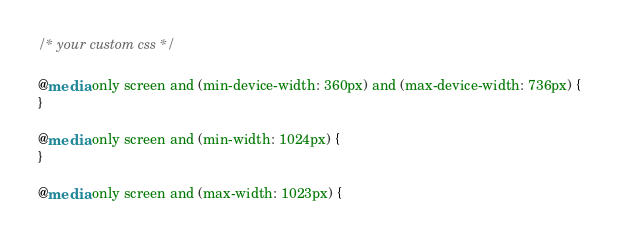<code> <loc_0><loc_0><loc_500><loc_500><_CSS_>/* your custom css */

@media only screen and (min-device-width: 360px) and (max-device-width: 736px) {
}

@media only screen and (min-width: 1024px) {
}

@media only screen and (max-width: 1023px) {</code> 